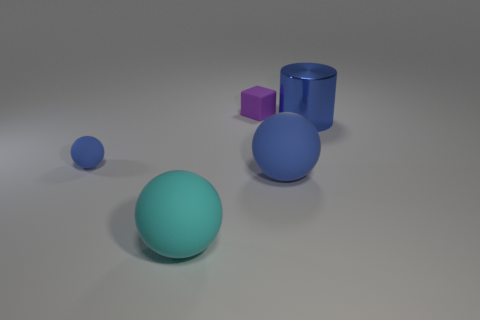Subtract all large blue spheres. How many spheres are left? 2 Add 1 large cyan shiny cubes. How many objects exist? 6 Subtract all purple cubes. How many blue spheres are left? 2 Subtract 1 spheres. How many spheres are left? 2 Subtract all blue balls. How many balls are left? 1 Subtract all cubes. How many objects are left? 4 Add 4 big balls. How many big balls are left? 6 Add 3 blue matte balls. How many blue matte balls exist? 5 Subtract 1 cyan balls. How many objects are left? 4 Subtract all red balls. Subtract all cyan cylinders. How many balls are left? 3 